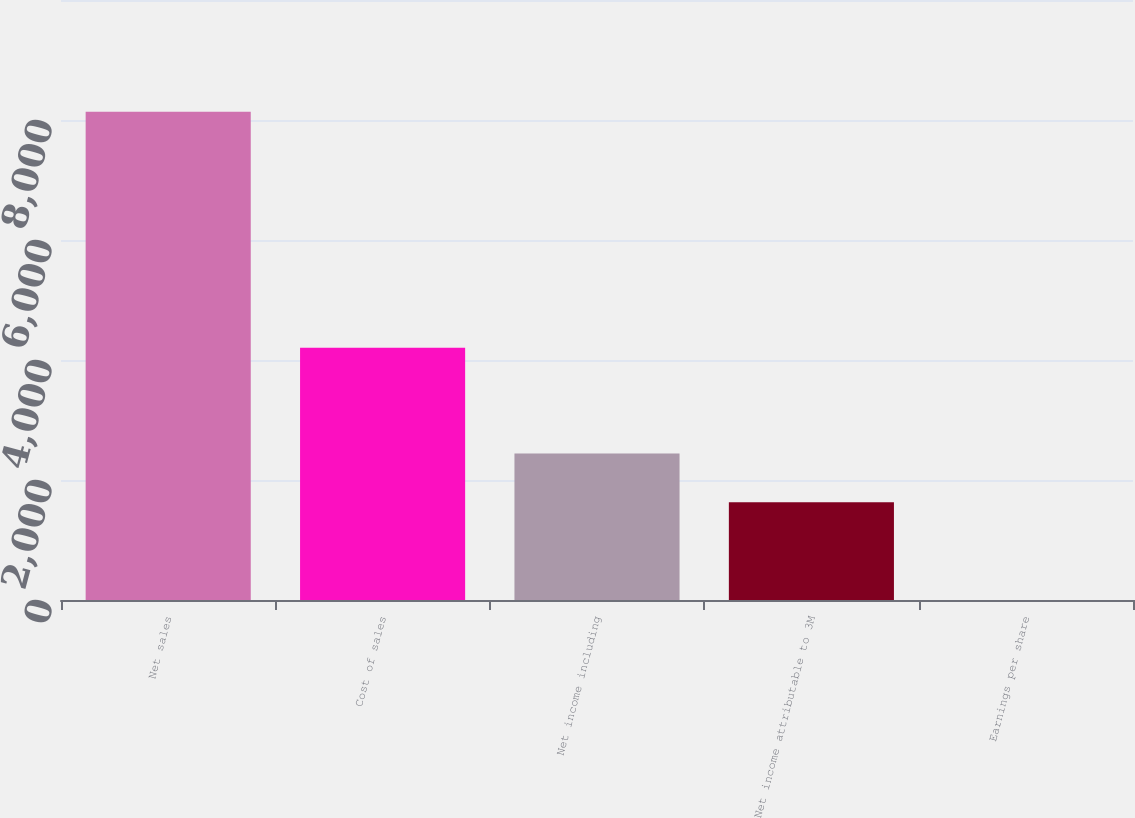<chart> <loc_0><loc_0><loc_500><loc_500><bar_chart><fcel>Net sales<fcel>Cost of sales<fcel>Net income including<fcel>Net income attributable to 3M<fcel>Earnings per share<nl><fcel>8137<fcel>4205<fcel>2442.48<fcel>1628.98<fcel>1.98<nl></chart> 